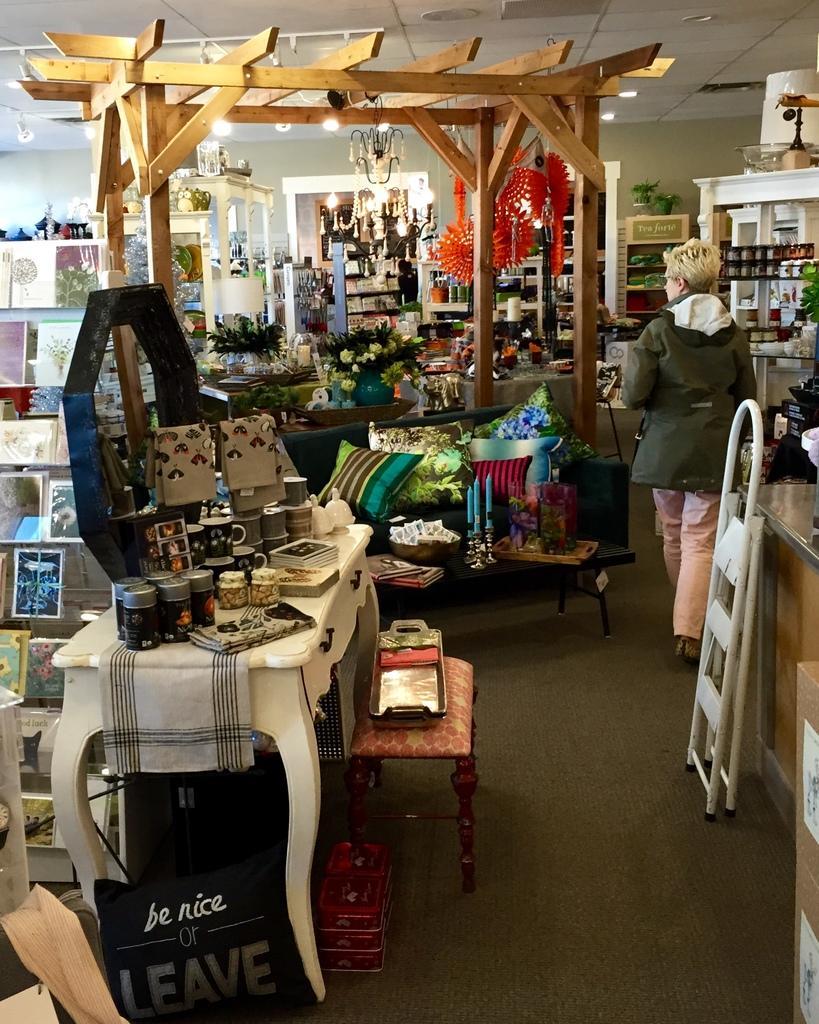Describe this image in one or two sentences. Here we can see a woman walking on the floor, and at back here is the table and some objects on it, and here are the pillows, and here is the chandelier, and at above here is the roof. 